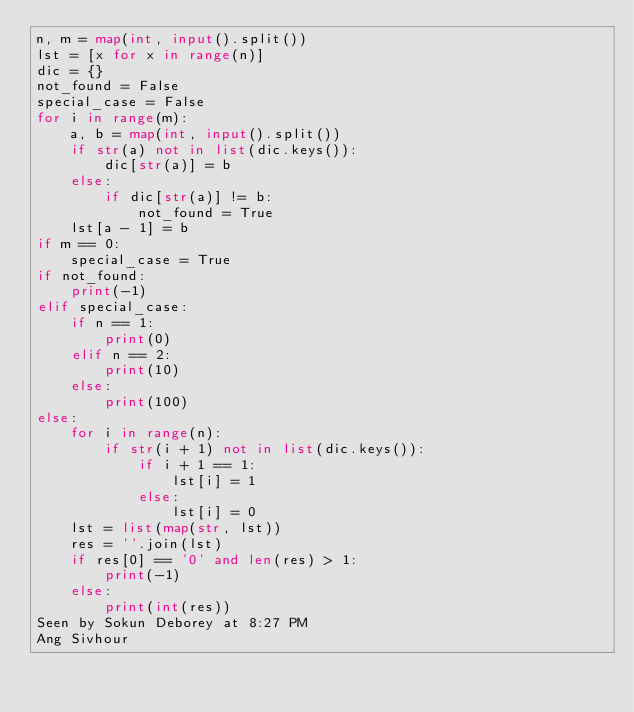<code> <loc_0><loc_0><loc_500><loc_500><_Python_>n, m = map(int, input().split())
lst = [x for x in range(n)]
dic = {}
not_found = False
special_case = False
for i in range(m):
    a, b = map(int, input().split())
    if str(a) not in list(dic.keys()):
        dic[str(a)] = b
    else:
        if dic[str(a)] != b:
            not_found = True
    lst[a - 1] = b
if m == 0:
    special_case = True
if not_found:
    print(-1)
elif special_case:
    if n == 1:
        print(0)
    elif n == 2:
        print(10)
    else:
        print(100)
else:
    for i in range(n):
        if str(i + 1) not in list(dic.keys()):
            if i + 1 == 1:
                lst[i] = 1
            else:
                lst[i] = 0
    lst = list(map(str, lst))
    res = ''.join(lst)
    if res[0] == '0' and len(res) > 1:
        print(-1)
    else:
        print(int(res))
Seen by Sokun Deborey at 8:27 PM
Ang Sivhour</code> 